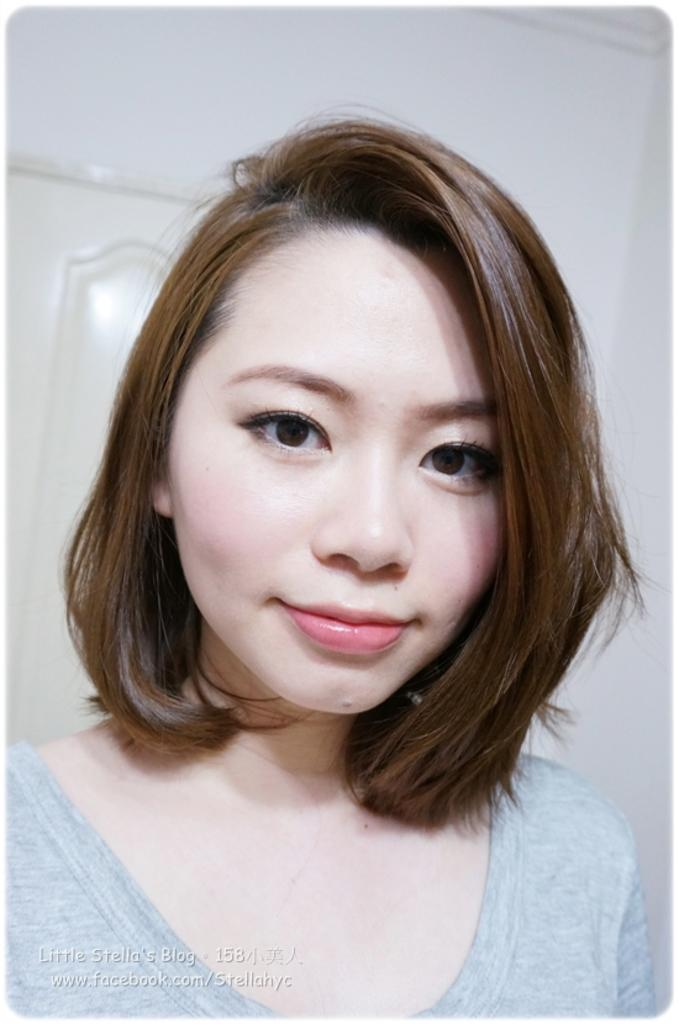Who is present in the image? There is a woman in the image. What is the woman wearing? The woman is wearing a grey dress. What can be seen in the background of the image? There is a white wall and a door in the background of the image. What is the woman attempting to write on the wall in the image? There is no indication in the image that the woman is attempting to write on the wall, and no writing materials are visible. 